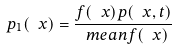Convert formula to latex. <formula><loc_0><loc_0><loc_500><loc_500>p _ { 1 } ( \ x ) = \frac { f ( \ x ) p ( \ x , t ) } { \ m e a n { f ( \ x ) } }</formula> 